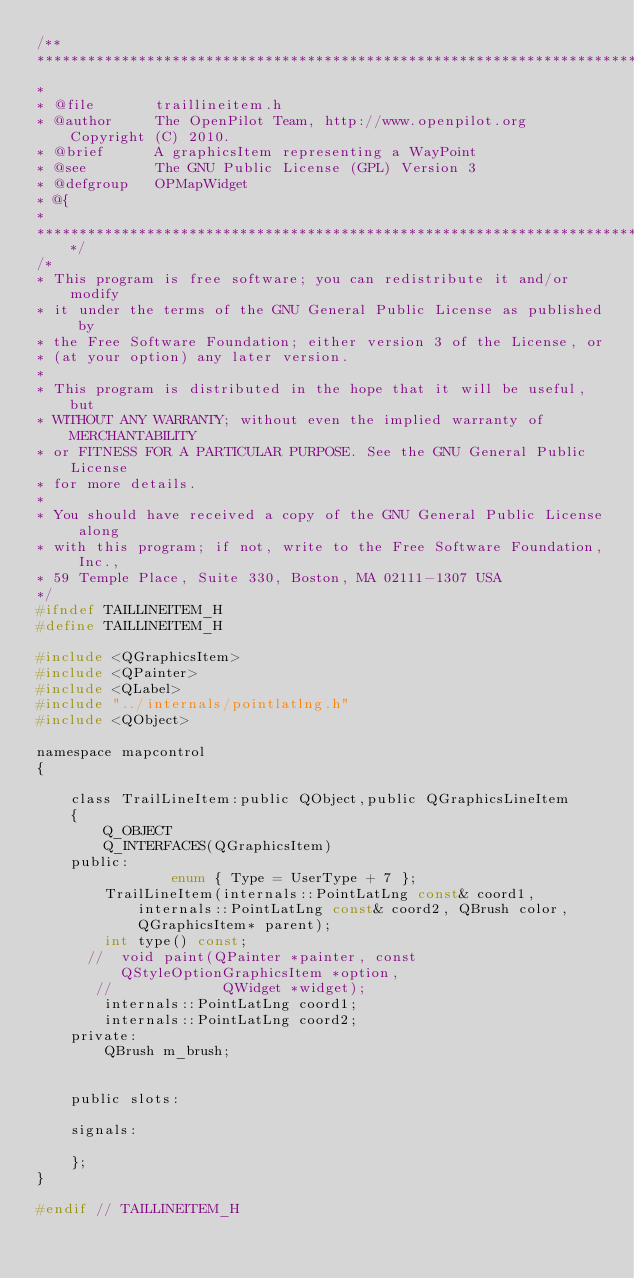Convert code to text. <code><loc_0><loc_0><loc_500><loc_500><_C_>/**
******************************************************************************
*
* @file       traillineitem.h
* @author     The OpenPilot Team, http://www.openpilot.org Copyright (C) 2010.
* @brief      A graphicsItem representing a WayPoint
* @see        The GNU Public License (GPL) Version 3
* @defgroup   OPMapWidget
* @{
*
*****************************************************************************/
/*
* This program is free software; you can redistribute it and/or modify
* it under the terms of the GNU General Public License as published by
* the Free Software Foundation; either version 3 of the License, or
* (at your option) any later version.
*
* This program is distributed in the hope that it will be useful, but
* WITHOUT ANY WARRANTY; without even the implied warranty of MERCHANTABILITY
* or FITNESS FOR A PARTICULAR PURPOSE. See the GNU General Public License
* for more details.
*
* You should have received a copy of the GNU General Public License along
* with this program; if not, write to the Free Software Foundation, Inc.,
* 59 Temple Place, Suite 330, Boston, MA 02111-1307 USA
*/
#ifndef TAILLINEITEM_H
#define TAILLINEITEM_H

#include <QGraphicsItem>
#include <QPainter>
#include <QLabel>
#include "../internals/pointlatlng.h"
#include <QObject>

namespace mapcontrol
{

    class TrailLineItem:public QObject,public QGraphicsLineItem
    {
        Q_OBJECT
        Q_INTERFACES(QGraphicsItem)
    public:
                enum { Type = UserType + 7 };
        TrailLineItem(internals::PointLatLng const& coord1,internals::PointLatLng const& coord2, QBrush color, QGraphicsItem* parent);
        int type() const;
      //  void paint(QPainter *painter, const QStyleOptionGraphicsItem *option,
       //             QWidget *widget);
        internals::PointLatLng coord1;
        internals::PointLatLng coord2;
    private:
        QBrush m_brush;


    public slots:

    signals:

    };
}

#endif // TAILLINEITEM_H
</code> 